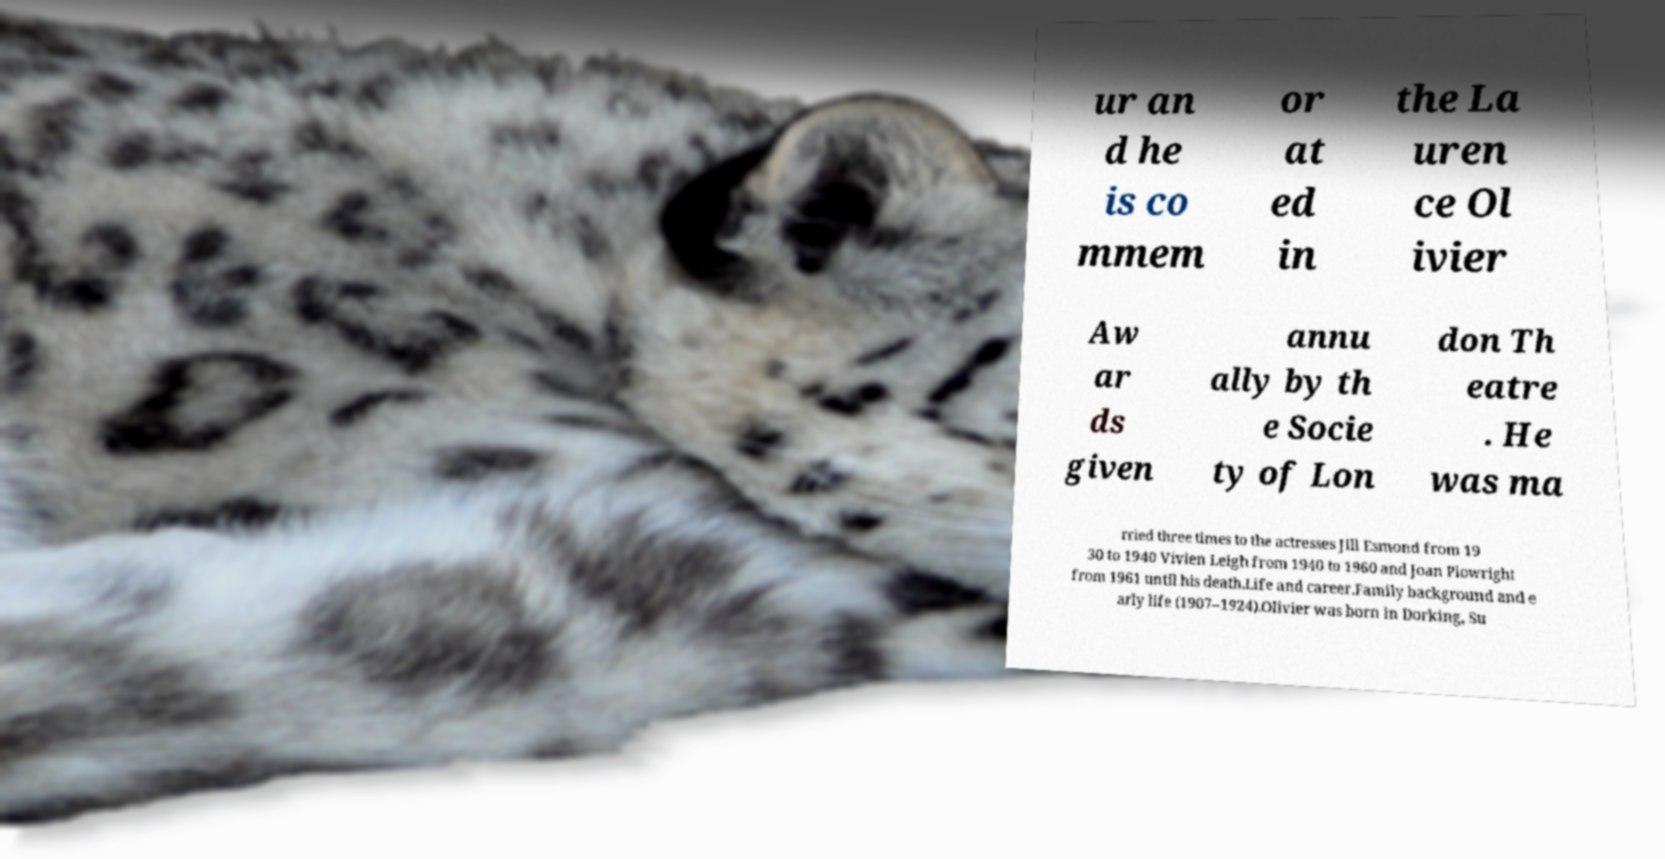Please read and relay the text visible in this image. What does it say? ur an d he is co mmem or at ed in the La uren ce Ol ivier Aw ar ds given annu ally by th e Socie ty of Lon don Th eatre . He was ma rried three times to the actresses Jill Esmond from 19 30 to 1940 Vivien Leigh from 1940 to 1960 and Joan Plowright from 1961 until his death.Life and career.Family background and e arly life (1907–1924).Olivier was born in Dorking, Su 